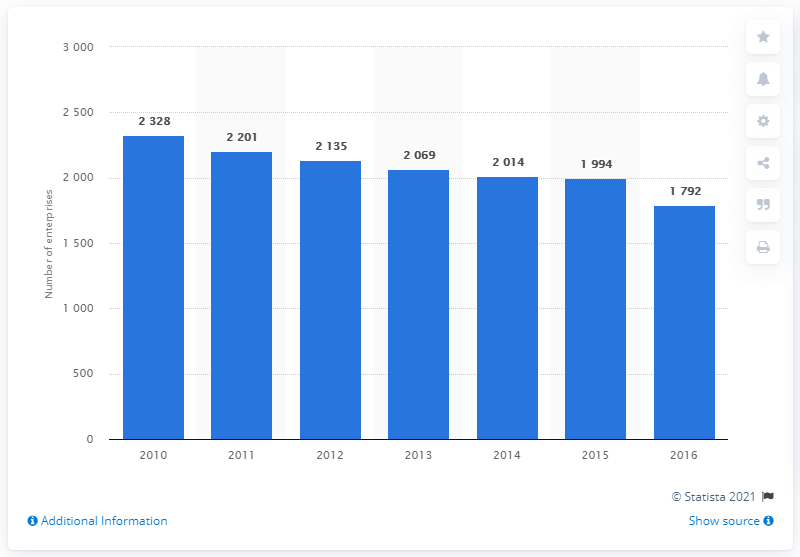Mention a couple of crucial points in this snapshot. In 2016, there were 1,792 travel agency and tour operator enterprises operating in Switzerland. 